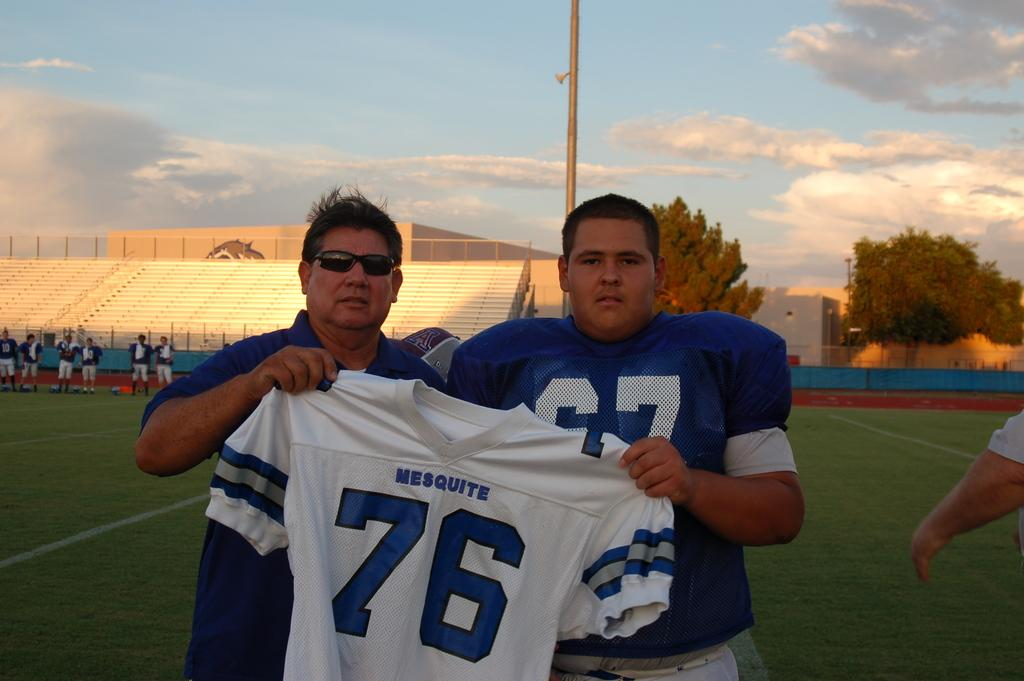Provide a one-sentence caption for the provided image. Two men in blue proudly hold up the number 76 jersey. 